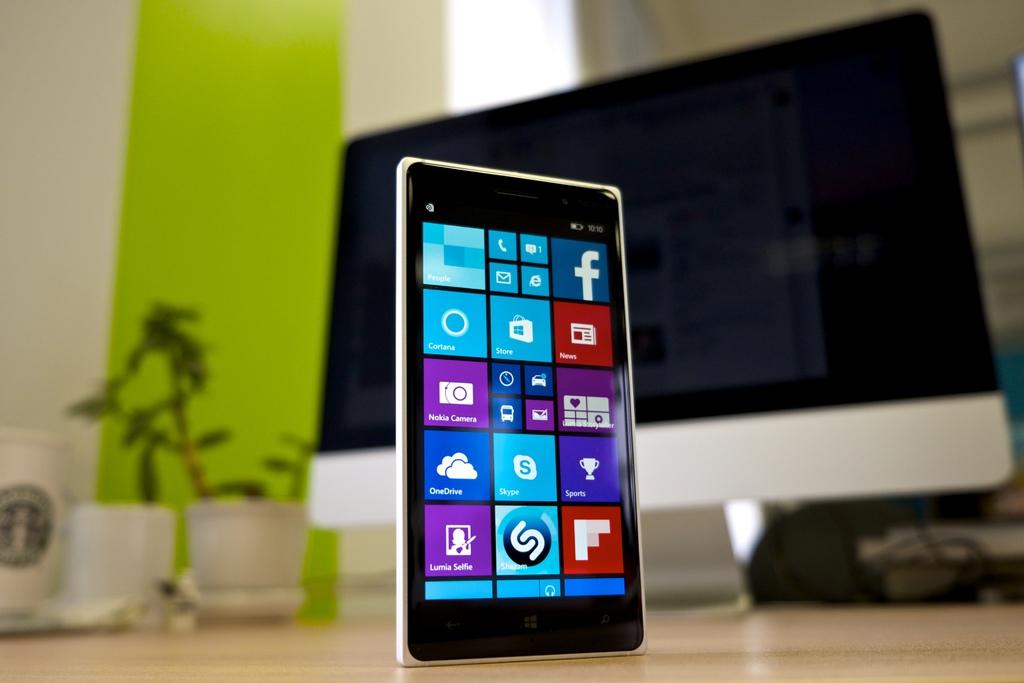Can you see more social networks apps?
Make the answer very short. Yes. What does the icon with the cloud mean?
Your answer should be very brief. Onedrive. 